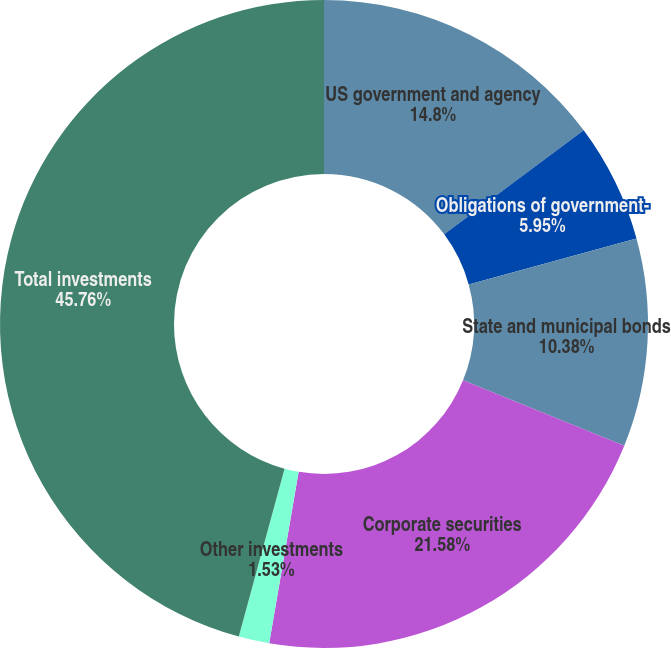Convert chart to OTSL. <chart><loc_0><loc_0><loc_500><loc_500><pie_chart><fcel>US government and agency<fcel>Obligations of government-<fcel>State and municipal bonds<fcel>Corporate securities<fcel>Other investments<fcel>Total investments<nl><fcel>14.8%<fcel>5.95%<fcel>10.38%<fcel>21.58%<fcel>1.53%<fcel>45.77%<nl></chart> 